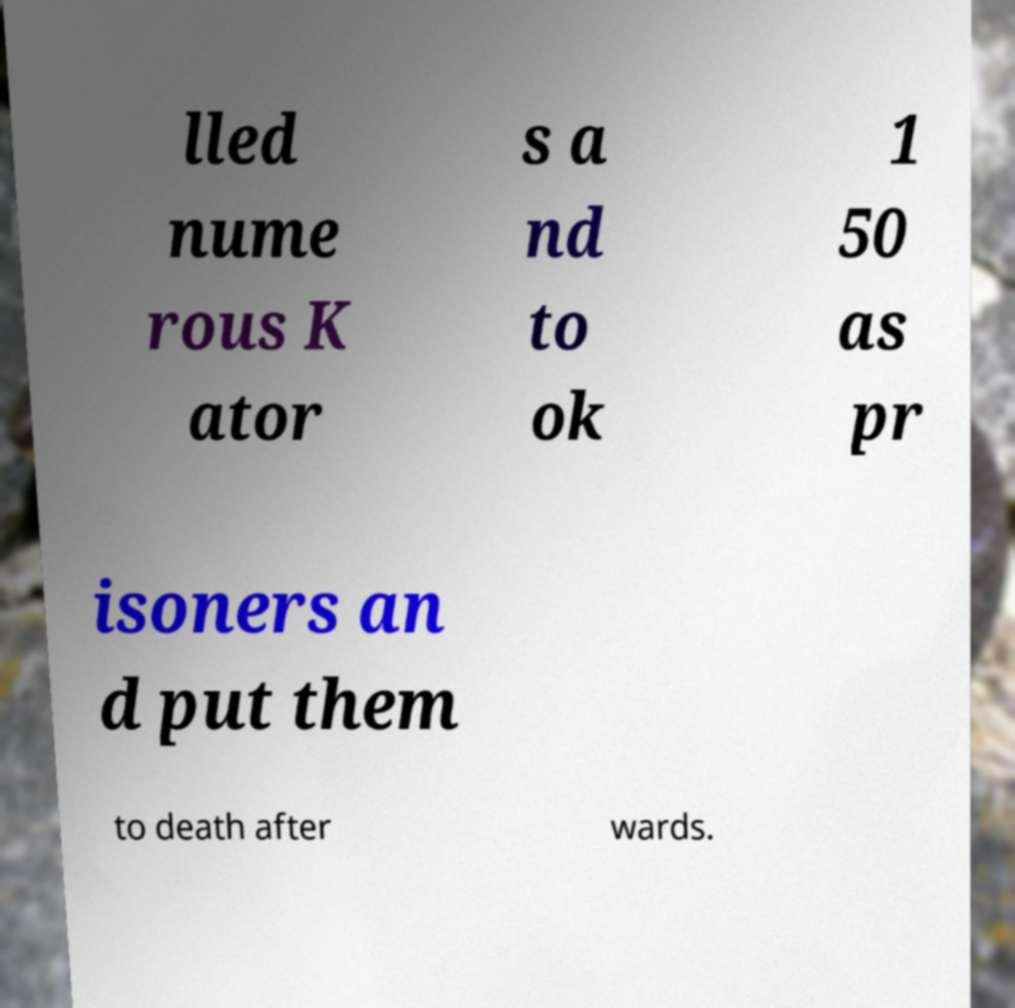Can you accurately transcribe the text from the provided image for me? lled nume rous K ator s a nd to ok 1 50 as pr isoners an d put them to death after wards. 